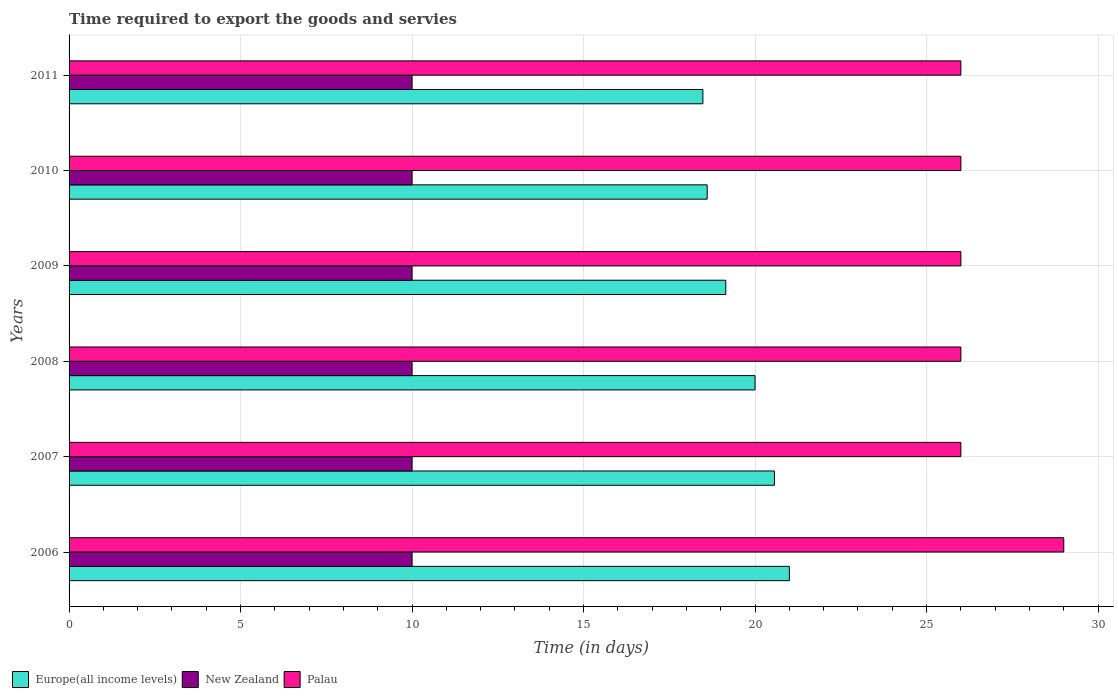How many different coloured bars are there?
Your answer should be very brief. 3. Are the number of bars per tick equal to the number of legend labels?
Offer a very short reply. Yes. Are the number of bars on each tick of the Y-axis equal?
Offer a very short reply. Yes. How many bars are there on the 1st tick from the bottom?
Make the answer very short. 3. What is the number of days required to export the goods and services in New Zealand in 2007?
Offer a terse response. 10. Across all years, what is the maximum number of days required to export the goods and services in Palau?
Your response must be concise. 29. Across all years, what is the minimum number of days required to export the goods and services in Palau?
Offer a very short reply. 26. In which year was the number of days required to export the goods and services in Palau minimum?
Your answer should be very brief. 2007. What is the total number of days required to export the goods and services in Europe(all income levels) in the graph?
Make the answer very short. 117.79. What is the difference between the number of days required to export the goods and services in New Zealand in 2006 and that in 2007?
Ensure brevity in your answer.  0. What is the difference between the number of days required to export the goods and services in Palau in 2009 and the number of days required to export the goods and services in New Zealand in 2007?
Provide a short and direct response. 16. What is the average number of days required to export the goods and services in Palau per year?
Ensure brevity in your answer.  26.5. In the year 2006, what is the difference between the number of days required to export the goods and services in New Zealand and number of days required to export the goods and services in Palau?
Ensure brevity in your answer.  -19. In how many years, is the number of days required to export the goods and services in Palau greater than 7 days?
Make the answer very short. 6. What is the difference between the highest and the lowest number of days required to export the goods and services in Palau?
Offer a terse response. 3. In how many years, is the number of days required to export the goods and services in Europe(all income levels) greater than the average number of days required to export the goods and services in Europe(all income levels) taken over all years?
Your answer should be compact. 3. Is the sum of the number of days required to export the goods and services in Palau in 2006 and 2010 greater than the maximum number of days required to export the goods and services in Europe(all income levels) across all years?
Your answer should be compact. Yes. What does the 2nd bar from the top in 2010 represents?
Provide a succinct answer. New Zealand. What does the 2nd bar from the bottom in 2010 represents?
Offer a terse response. New Zealand. Is it the case that in every year, the sum of the number of days required to export the goods and services in Europe(all income levels) and number of days required to export the goods and services in Palau is greater than the number of days required to export the goods and services in New Zealand?
Make the answer very short. Yes. How many bars are there?
Your response must be concise. 18. How many years are there in the graph?
Your response must be concise. 6. Where does the legend appear in the graph?
Keep it short and to the point. Bottom left. What is the title of the graph?
Make the answer very short. Time required to export the goods and servies. Does "Cayman Islands" appear as one of the legend labels in the graph?
Provide a short and direct response. No. What is the label or title of the X-axis?
Offer a very short reply. Time (in days). What is the label or title of the Y-axis?
Keep it short and to the point. Years. What is the Time (in days) in Palau in 2006?
Your answer should be very brief. 29. What is the Time (in days) of Europe(all income levels) in 2007?
Make the answer very short. 20.57. What is the Time (in days) of New Zealand in 2008?
Provide a succinct answer. 10. What is the Time (in days) in Palau in 2008?
Your response must be concise. 26. What is the Time (in days) of Europe(all income levels) in 2009?
Your answer should be compact. 19.15. What is the Time (in days) of New Zealand in 2009?
Your answer should be compact. 10. What is the Time (in days) in Palau in 2009?
Your answer should be very brief. 26. What is the Time (in days) in Europe(all income levels) in 2010?
Make the answer very short. 18.6. What is the Time (in days) in New Zealand in 2010?
Provide a short and direct response. 10. What is the Time (in days) of Europe(all income levels) in 2011?
Provide a succinct answer. 18.48. What is the Time (in days) of New Zealand in 2011?
Provide a short and direct response. 10. Across all years, what is the maximum Time (in days) of New Zealand?
Offer a very short reply. 10. Across all years, what is the maximum Time (in days) of Palau?
Offer a terse response. 29. Across all years, what is the minimum Time (in days) in Europe(all income levels)?
Your answer should be compact. 18.48. Across all years, what is the minimum Time (in days) of Palau?
Provide a short and direct response. 26. What is the total Time (in days) in Europe(all income levels) in the graph?
Offer a very short reply. 117.79. What is the total Time (in days) in Palau in the graph?
Make the answer very short. 159. What is the difference between the Time (in days) of Europe(all income levels) in 2006 and that in 2007?
Offer a terse response. 0.43. What is the difference between the Time (in days) of Europe(all income levels) in 2006 and that in 2008?
Provide a short and direct response. 1. What is the difference between the Time (in days) of Palau in 2006 and that in 2008?
Provide a short and direct response. 3. What is the difference between the Time (in days) of Europe(all income levels) in 2006 and that in 2009?
Your answer should be very brief. 1.85. What is the difference between the Time (in days) of New Zealand in 2006 and that in 2009?
Ensure brevity in your answer.  0. What is the difference between the Time (in days) of Europe(all income levels) in 2006 and that in 2010?
Keep it short and to the point. 2.4. What is the difference between the Time (in days) of New Zealand in 2006 and that in 2010?
Offer a terse response. 0. What is the difference between the Time (in days) of Europe(all income levels) in 2006 and that in 2011?
Your answer should be very brief. 2.52. What is the difference between the Time (in days) in New Zealand in 2006 and that in 2011?
Provide a short and direct response. 0. What is the difference between the Time (in days) in Palau in 2006 and that in 2011?
Keep it short and to the point. 3. What is the difference between the Time (in days) of Europe(all income levels) in 2007 and that in 2008?
Provide a short and direct response. 0.57. What is the difference between the Time (in days) in New Zealand in 2007 and that in 2008?
Ensure brevity in your answer.  0. What is the difference between the Time (in days) in Europe(all income levels) in 2007 and that in 2009?
Provide a short and direct response. 1.42. What is the difference between the Time (in days) of Palau in 2007 and that in 2009?
Offer a very short reply. 0. What is the difference between the Time (in days) of Europe(all income levels) in 2007 and that in 2010?
Ensure brevity in your answer.  1.96. What is the difference between the Time (in days) in Europe(all income levels) in 2007 and that in 2011?
Your answer should be very brief. 2.09. What is the difference between the Time (in days) of New Zealand in 2007 and that in 2011?
Ensure brevity in your answer.  0. What is the difference between the Time (in days) in Europe(all income levels) in 2008 and that in 2009?
Give a very brief answer. 0.85. What is the difference between the Time (in days) in New Zealand in 2008 and that in 2009?
Provide a succinct answer. 0. What is the difference between the Time (in days) of Palau in 2008 and that in 2009?
Your answer should be very brief. 0. What is the difference between the Time (in days) of Europe(all income levels) in 2008 and that in 2010?
Your answer should be very brief. 1.4. What is the difference between the Time (in days) in New Zealand in 2008 and that in 2010?
Offer a very short reply. 0. What is the difference between the Time (in days) in Palau in 2008 and that in 2010?
Give a very brief answer. 0. What is the difference between the Time (in days) in Europe(all income levels) in 2008 and that in 2011?
Offer a terse response. 1.52. What is the difference between the Time (in days) of New Zealand in 2008 and that in 2011?
Ensure brevity in your answer.  0. What is the difference between the Time (in days) of Palau in 2008 and that in 2011?
Offer a terse response. 0. What is the difference between the Time (in days) in Europe(all income levels) in 2009 and that in 2010?
Provide a short and direct response. 0.54. What is the difference between the Time (in days) in Palau in 2009 and that in 2010?
Make the answer very short. 0. What is the difference between the Time (in days) of Europe(all income levels) in 2009 and that in 2011?
Your answer should be compact. 0.67. What is the difference between the Time (in days) in New Zealand in 2009 and that in 2011?
Your response must be concise. 0. What is the difference between the Time (in days) in Palau in 2009 and that in 2011?
Your response must be concise. 0. What is the difference between the Time (in days) of Europe(all income levels) in 2010 and that in 2011?
Your response must be concise. 0.12. What is the difference between the Time (in days) in Palau in 2010 and that in 2011?
Offer a very short reply. 0. What is the difference between the Time (in days) in Europe(all income levels) in 2006 and the Time (in days) in Palau in 2008?
Your answer should be very brief. -5. What is the difference between the Time (in days) in Europe(all income levels) in 2006 and the Time (in days) in New Zealand in 2009?
Offer a very short reply. 11. What is the difference between the Time (in days) in Europe(all income levels) in 2006 and the Time (in days) in New Zealand in 2010?
Make the answer very short. 11. What is the difference between the Time (in days) of Europe(all income levels) in 2006 and the Time (in days) of Palau in 2010?
Make the answer very short. -5. What is the difference between the Time (in days) of New Zealand in 2006 and the Time (in days) of Palau in 2010?
Provide a succinct answer. -16. What is the difference between the Time (in days) of Europe(all income levels) in 2006 and the Time (in days) of New Zealand in 2011?
Keep it short and to the point. 11. What is the difference between the Time (in days) in Europe(all income levels) in 2006 and the Time (in days) in Palau in 2011?
Make the answer very short. -5. What is the difference between the Time (in days) of New Zealand in 2006 and the Time (in days) of Palau in 2011?
Ensure brevity in your answer.  -16. What is the difference between the Time (in days) of Europe(all income levels) in 2007 and the Time (in days) of New Zealand in 2008?
Give a very brief answer. 10.57. What is the difference between the Time (in days) of Europe(all income levels) in 2007 and the Time (in days) of Palau in 2008?
Make the answer very short. -5.43. What is the difference between the Time (in days) of Europe(all income levels) in 2007 and the Time (in days) of New Zealand in 2009?
Keep it short and to the point. 10.57. What is the difference between the Time (in days) in Europe(all income levels) in 2007 and the Time (in days) in Palau in 2009?
Your response must be concise. -5.43. What is the difference between the Time (in days) in New Zealand in 2007 and the Time (in days) in Palau in 2009?
Provide a succinct answer. -16. What is the difference between the Time (in days) of Europe(all income levels) in 2007 and the Time (in days) of New Zealand in 2010?
Keep it short and to the point. 10.57. What is the difference between the Time (in days) in Europe(all income levels) in 2007 and the Time (in days) in Palau in 2010?
Offer a terse response. -5.43. What is the difference between the Time (in days) in Europe(all income levels) in 2007 and the Time (in days) in New Zealand in 2011?
Give a very brief answer. 10.57. What is the difference between the Time (in days) in Europe(all income levels) in 2007 and the Time (in days) in Palau in 2011?
Your answer should be compact. -5.43. What is the difference between the Time (in days) in New Zealand in 2007 and the Time (in days) in Palau in 2011?
Ensure brevity in your answer.  -16. What is the difference between the Time (in days) in New Zealand in 2008 and the Time (in days) in Palau in 2009?
Keep it short and to the point. -16. What is the difference between the Time (in days) of Europe(all income levels) in 2008 and the Time (in days) of Palau in 2010?
Offer a terse response. -6. What is the difference between the Time (in days) in New Zealand in 2008 and the Time (in days) in Palau in 2010?
Give a very brief answer. -16. What is the difference between the Time (in days) of Europe(all income levels) in 2009 and the Time (in days) of New Zealand in 2010?
Your answer should be compact. 9.15. What is the difference between the Time (in days) in Europe(all income levels) in 2009 and the Time (in days) in Palau in 2010?
Give a very brief answer. -6.85. What is the difference between the Time (in days) of New Zealand in 2009 and the Time (in days) of Palau in 2010?
Your answer should be very brief. -16. What is the difference between the Time (in days) of Europe(all income levels) in 2009 and the Time (in days) of New Zealand in 2011?
Offer a very short reply. 9.15. What is the difference between the Time (in days) of Europe(all income levels) in 2009 and the Time (in days) of Palau in 2011?
Provide a short and direct response. -6.85. What is the difference between the Time (in days) of New Zealand in 2009 and the Time (in days) of Palau in 2011?
Ensure brevity in your answer.  -16. What is the difference between the Time (in days) in Europe(all income levels) in 2010 and the Time (in days) in New Zealand in 2011?
Offer a very short reply. 8.6. What is the difference between the Time (in days) of Europe(all income levels) in 2010 and the Time (in days) of Palau in 2011?
Provide a short and direct response. -7.4. What is the difference between the Time (in days) of New Zealand in 2010 and the Time (in days) of Palau in 2011?
Offer a terse response. -16. What is the average Time (in days) of Europe(all income levels) per year?
Give a very brief answer. 19.63. What is the average Time (in days) of New Zealand per year?
Provide a short and direct response. 10. What is the average Time (in days) in Palau per year?
Your answer should be very brief. 26.5. In the year 2006, what is the difference between the Time (in days) of Europe(all income levels) and Time (in days) of Palau?
Offer a terse response. -8. In the year 2006, what is the difference between the Time (in days) of New Zealand and Time (in days) of Palau?
Your answer should be very brief. -19. In the year 2007, what is the difference between the Time (in days) of Europe(all income levels) and Time (in days) of New Zealand?
Your answer should be very brief. 10.57. In the year 2007, what is the difference between the Time (in days) of Europe(all income levels) and Time (in days) of Palau?
Offer a terse response. -5.43. In the year 2008, what is the difference between the Time (in days) in Europe(all income levels) and Time (in days) in Palau?
Offer a very short reply. -6. In the year 2008, what is the difference between the Time (in days) of New Zealand and Time (in days) of Palau?
Your response must be concise. -16. In the year 2009, what is the difference between the Time (in days) of Europe(all income levels) and Time (in days) of New Zealand?
Your answer should be very brief. 9.15. In the year 2009, what is the difference between the Time (in days) of Europe(all income levels) and Time (in days) of Palau?
Keep it short and to the point. -6.85. In the year 2009, what is the difference between the Time (in days) of New Zealand and Time (in days) of Palau?
Make the answer very short. -16. In the year 2010, what is the difference between the Time (in days) in Europe(all income levels) and Time (in days) in New Zealand?
Give a very brief answer. 8.6. In the year 2010, what is the difference between the Time (in days) in Europe(all income levels) and Time (in days) in Palau?
Keep it short and to the point. -7.4. In the year 2011, what is the difference between the Time (in days) of Europe(all income levels) and Time (in days) of New Zealand?
Offer a terse response. 8.48. In the year 2011, what is the difference between the Time (in days) in Europe(all income levels) and Time (in days) in Palau?
Keep it short and to the point. -7.52. In the year 2011, what is the difference between the Time (in days) of New Zealand and Time (in days) of Palau?
Provide a short and direct response. -16. What is the ratio of the Time (in days) in Europe(all income levels) in 2006 to that in 2007?
Provide a short and direct response. 1.02. What is the ratio of the Time (in days) of Palau in 2006 to that in 2007?
Your answer should be compact. 1.12. What is the ratio of the Time (in days) in Palau in 2006 to that in 2008?
Give a very brief answer. 1.12. What is the ratio of the Time (in days) in Europe(all income levels) in 2006 to that in 2009?
Ensure brevity in your answer.  1.1. What is the ratio of the Time (in days) of Palau in 2006 to that in 2009?
Your answer should be very brief. 1.12. What is the ratio of the Time (in days) in Europe(all income levels) in 2006 to that in 2010?
Your answer should be very brief. 1.13. What is the ratio of the Time (in days) in Palau in 2006 to that in 2010?
Offer a terse response. 1.12. What is the ratio of the Time (in days) in Europe(all income levels) in 2006 to that in 2011?
Your answer should be compact. 1.14. What is the ratio of the Time (in days) in New Zealand in 2006 to that in 2011?
Provide a short and direct response. 1. What is the ratio of the Time (in days) in Palau in 2006 to that in 2011?
Your answer should be compact. 1.12. What is the ratio of the Time (in days) of Europe(all income levels) in 2007 to that in 2008?
Keep it short and to the point. 1.03. What is the ratio of the Time (in days) in Palau in 2007 to that in 2008?
Keep it short and to the point. 1. What is the ratio of the Time (in days) of Europe(all income levels) in 2007 to that in 2009?
Give a very brief answer. 1.07. What is the ratio of the Time (in days) in New Zealand in 2007 to that in 2009?
Offer a very short reply. 1. What is the ratio of the Time (in days) in Palau in 2007 to that in 2009?
Your answer should be very brief. 1. What is the ratio of the Time (in days) in Europe(all income levels) in 2007 to that in 2010?
Provide a succinct answer. 1.11. What is the ratio of the Time (in days) in New Zealand in 2007 to that in 2010?
Your answer should be very brief. 1. What is the ratio of the Time (in days) in Europe(all income levels) in 2007 to that in 2011?
Give a very brief answer. 1.11. What is the ratio of the Time (in days) of New Zealand in 2007 to that in 2011?
Offer a terse response. 1. What is the ratio of the Time (in days) of Palau in 2007 to that in 2011?
Give a very brief answer. 1. What is the ratio of the Time (in days) of Europe(all income levels) in 2008 to that in 2009?
Your response must be concise. 1.04. What is the ratio of the Time (in days) of New Zealand in 2008 to that in 2009?
Make the answer very short. 1. What is the ratio of the Time (in days) in Palau in 2008 to that in 2009?
Offer a very short reply. 1. What is the ratio of the Time (in days) of Europe(all income levels) in 2008 to that in 2010?
Make the answer very short. 1.07. What is the ratio of the Time (in days) of New Zealand in 2008 to that in 2010?
Provide a succinct answer. 1. What is the ratio of the Time (in days) in Palau in 2008 to that in 2010?
Offer a very short reply. 1. What is the ratio of the Time (in days) of Europe(all income levels) in 2008 to that in 2011?
Make the answer very short. 1.08. What is the ratio of the Time (in days) of New Zealand in 2008 to that in 2011?
Your answer should be compact. 1. What is the ratio of the Time (in days) of Palau in 2008 to that in 2011?
Your answer should be compact. 1. What is the ratio of the Time (in days) in Europe(all income levels) in 2009 to that in 2010?
Provide a short and direct response. 1.03. What is the ratio of the Time (in days) in New Zealand in 2009 to that in 2010?
Offer a very short reply. 1. What is the ratio of the Time (in days) in Europe(all income levels) in 2009 to that in 2011?
Offer a very short reply. 1.04. What is the ratio of the Time (in days) in Europe(all income levels) in 2010 to that in 2011?
Keep it short and to the point. 1.01. What is the ratio of the Time (in days) in New Zealand in 2010 to that in 2011?
Provide a short and direct response. 1. What is the difference between the highest and the second highest Time (in days) of Europe(all income levels)?
Provide a succinct answer. 0.43. What is the difference between the highest and the lowest Time (in days) of Europe(all income levels)?
Make the answer very short. 2.52. What is the difference between the highest and the lowest Time (in days) in Palau?
Offer a very short reply. 3. 